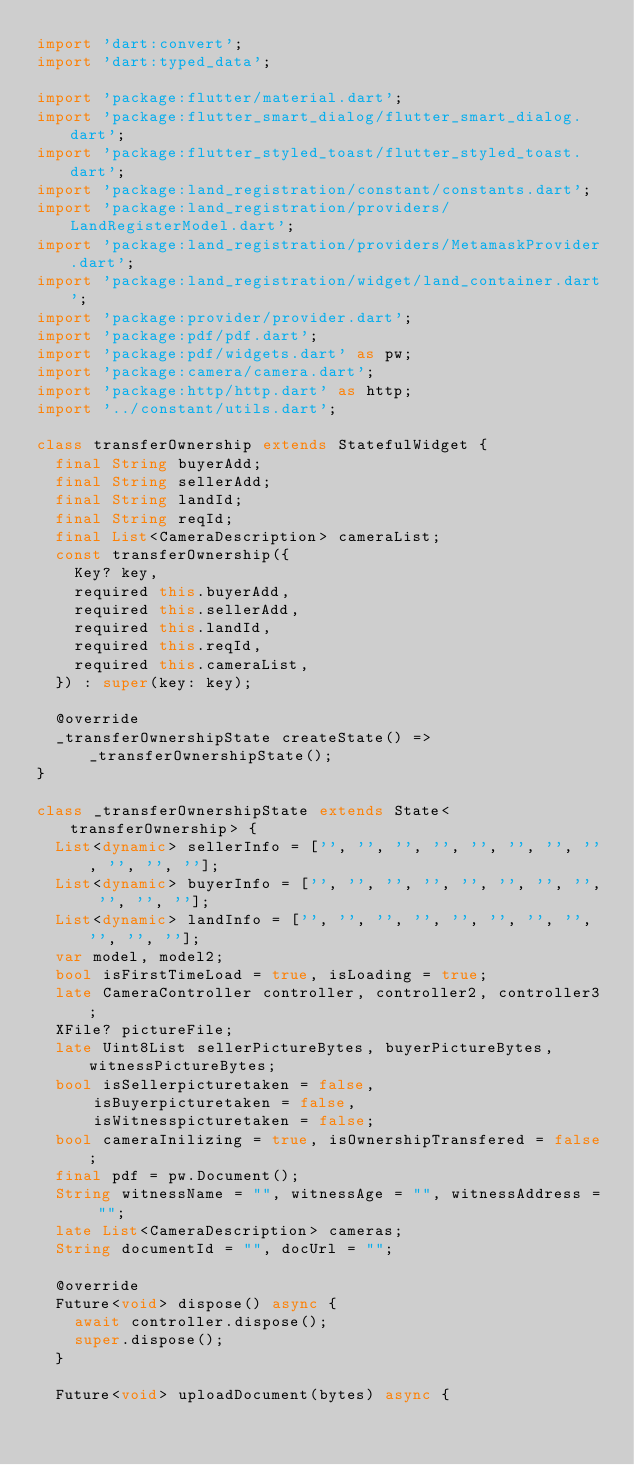<code> <loc_0><loc_0><loc_500><loc_500><_Dart_>import 'dart:convert';
import 'dart:typed_data';

import 'package:flutter/material.dart';
import 'package:flutter_smart_dialog/flutter_smart_dialog.dart';
import 'package:flutter_styled_toast/flutter_styled_toast.dart';
import 'package:land_registration/constant/constants.dart';
import 'package:land_registration/providers/LandRegisterModel.dart';
import 'package:land_registration/providers/MetamaskProvider.dart';
import 'package:land_registration/widget/land_container.dart';
import 'package:provider/provider.dart';
import 'package:pdf/pdf.dart';
import 'package:pdf/widgets.dart' as pw;
import 'package:camera/camera.dart';
import 'package:http/http.dart' as http;
import '../constant/utils.dart';

class transferOwnership extends StatefulWidget {
  final String buyerAdd;
  final String sellerAdd;
  final String landId;
  final String reqId;
  final List<CameraDescription> cameraList;
  const transferOwnership({
    Key? key,
    required this.buyerAdd,
    required this.sellerAdd,
    required this.landId,
    required this.reqId,
    required this.cameraList,
  }) : super(key: key);

  @override
  _transferOwnershipState createState() => _transferOwnershipState();
}

class _transferOwnershipState extends State<transferOwnership> {
  List<dynamic> sellerInfo = ['', '', '', '', '', '', '', '', '', '', ''];
  List<dynamic> buyerInfo = ['', '', '', '', '', '', '', '', '', '', ''];
  List<dynamic> landInfo = ['', '', '', '', '', '', '', '', '', '', ''];
  var model, model2;
  bool isFirstTimeLoad = true, isLoading = true;
  late CameraController controller, controller2, controller3;
  XFile? pictureFile;
  late Uint8List sellerPictureBytes, buyerPictureBytes, witnessPictureBytes;
  bool isSellerpicturetaken = false,
      isBuyerpicturetaken = false,
      isWitnesspicturetaken = false;
  bool cameraInilizing = true, isOwnershipTransfered = false;
  final pdf = pw.Document();
  String witnessName = "", witnessAge = "", witnessAddress = "";
  late List<CameraDescription> cameras;
  String documentId = "", docUrl = "";

  @override
  Future<void> dispose() async {
    await controller.dispose();
    super.dispose();
  }

  Future<void> uploadDocument(bytes) async {</code> 